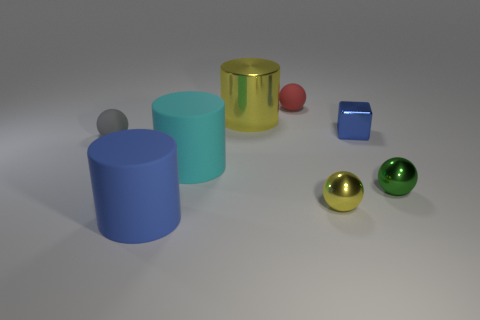What is the material of the yellow ball that is the same size as the blue metal object? The yellow ball appears to be made of a reflective material, similar to the blue object, suggesting that it could also be metallic. The sheen and reflections on its surface are consistent with a polished metal finish. 